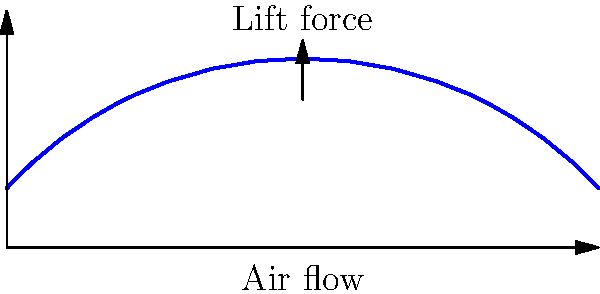During your flight to a remote company site, you observe the cross-section of the airplane wing. What principle explains the generation of lift, and how does the wing's shape contribute to this phenomenon? The generation of lift by an airplane wing can be explained through the following steps:

1. Wing Shape: The cross-section of an airplane wing (airfoil) is designed with a curved upper surface and a flatter lower surface.

2. Bernoulli's Principle: This principle states that an increase in the speed of a fluid occurs simultaneously with a decrease in pressure.

3. Air Flow: As the wing moves through the air:
   a) Air moving over the curved upper surface travels a longer distance than air moving under the wing.
   b) To meet at the trailing edge, the air over the top must move faster.

4. Pressure Difference: According to Bernoulli's principle:
   a) The faster-moving air on top creates a region of lower pressure.
   b) The slower-moving air below creates a region of higher pressure.

5. Lift Generation: The pressure difference between the lower and upper surfaces of the wing results in a net upward force, which we call lift.

6. Angle of Attack: The wing's angle relative to the oncoming air (angle of attack) can increase this effect, enhancing lift.

7. Newton's Third Law: The downward deflection of air by the wing also contributes to lift, as the air pushes back on the wing (action-reaction).

The combination of these factors, primarily driven by the wing's shape and Bernoulli's principle, generates the lift necessary for flight.
Answer: Bernoulli's principle and wing shape create a pressure difference, generating lift. 